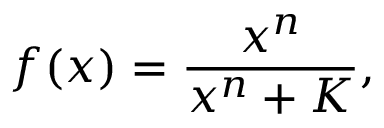<formula> <loc_0><loc_0><loc_500><loc_500>f ( x ) = \frac { x ^ { n } } { x ^ { n } + K } ,</formula> 